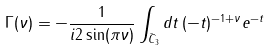Convert formula to latex. <formula><loc_0><loc_0><loc_500><loc_500>\Gamma ( \nu ) = - \frac { 1 } { i 2 \sin ( \pi \nu ) } \int _ { \bar { C } _ { 3 } } d t \, ( - t ) ^ { - 1 + \nu } e ^ { - t }</formula> 